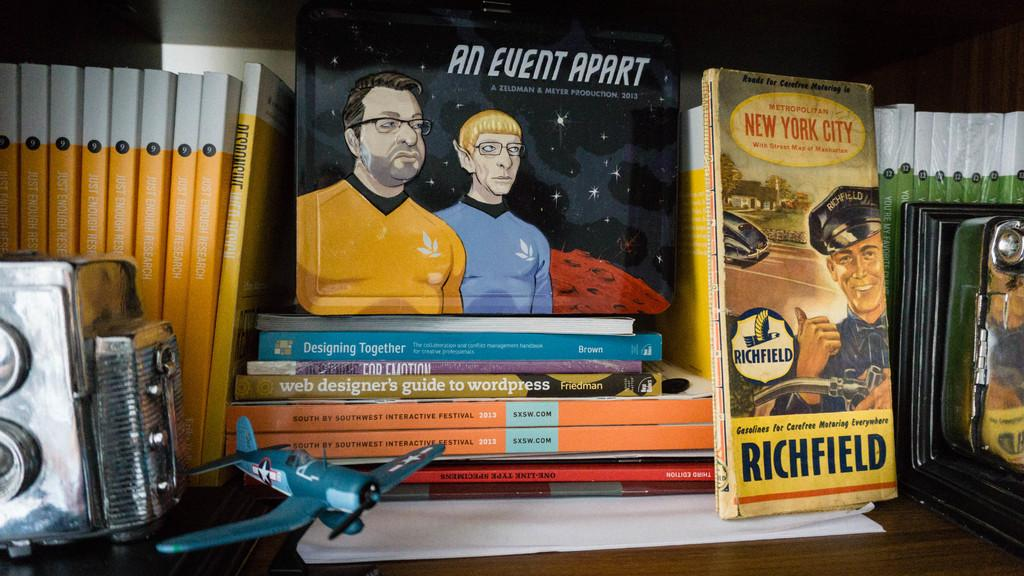<image>
Render a clear and concise summary of the photo. Several pulp art design books by various authors such as Richfield, Freeman and Brown. 